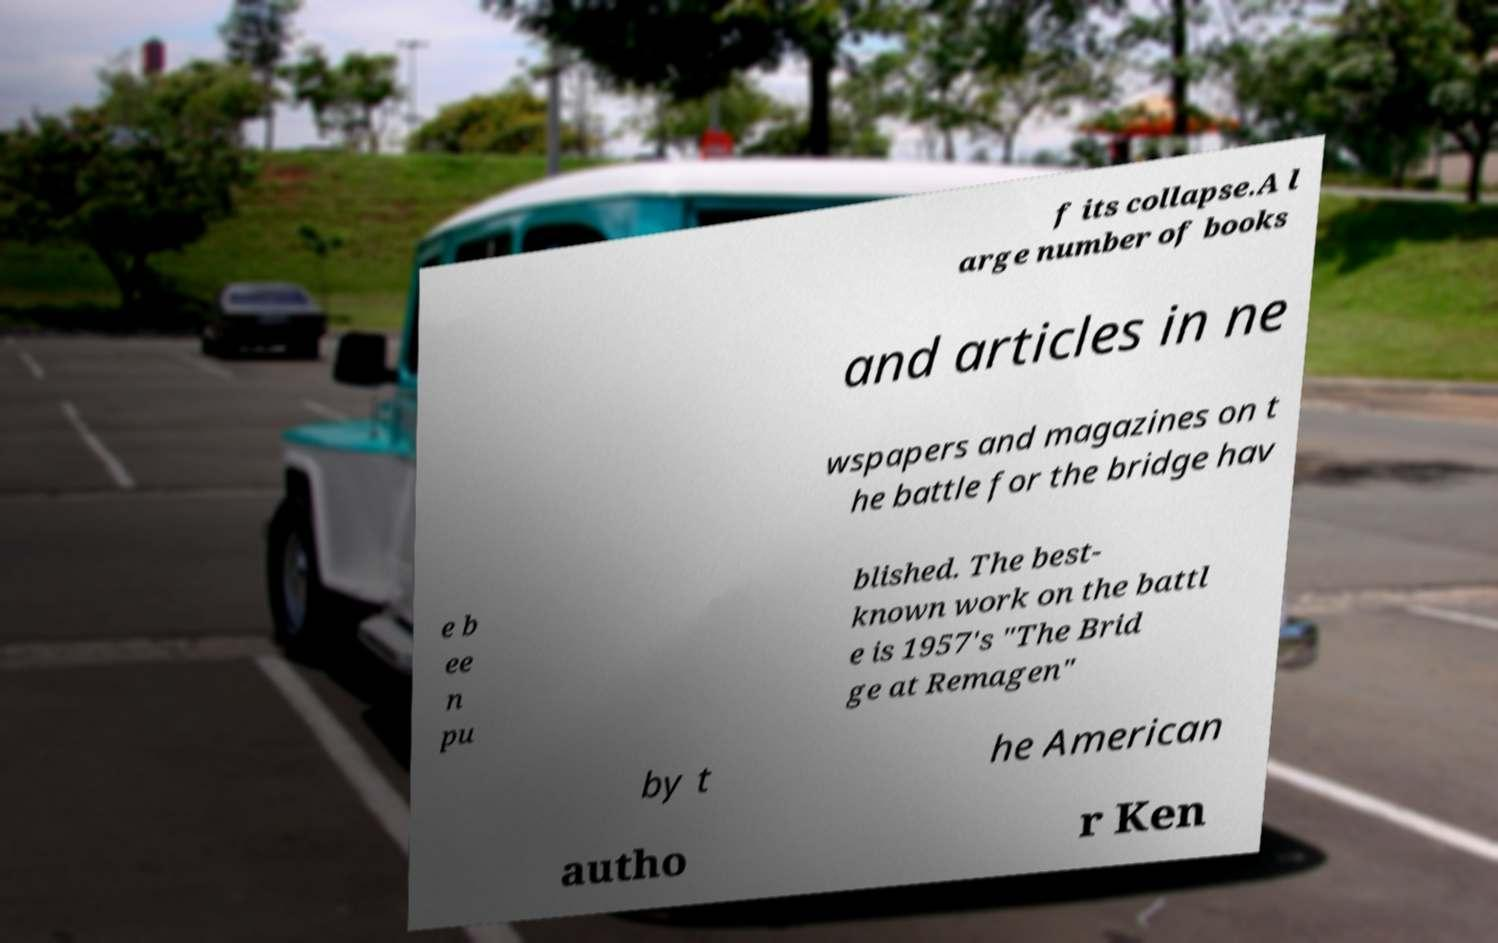I need the written content from this picture converted into text. Can you do that? f its collapse.A l arge number of books and articles in ne wspapers and magazines on t he battle for the bridge hav e b ee n pu blished. The best- known work on the battl e is 1957's "The Brid ge at Remagen" by t he American autho r Ken 